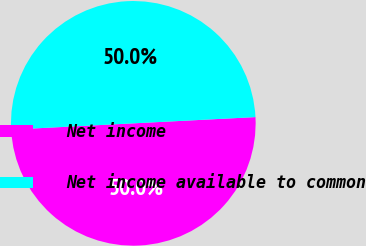<chart> <loc_0><loc_0><loc_500><loc_500><pie_chart><fcel>Net income<fcel>Net income available to common<nl><fcel>50.0%<fcel>50.0%<nl></chart> 